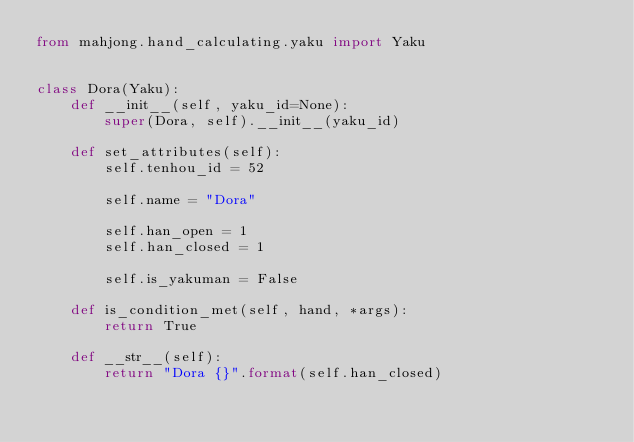<code> <loc_0><loc_0><loc_500><loc_500><_Python_>from mahjong.hand_calculating.yaku import Yaku


class Dora(Yaku):
    def __init__(self, yaku_id=None):
        super(Dora, self).__init__(yaku_id)

    def set_attributes(self):
        self.tenhou_id = 52

        self.name = "Dora"

        self.han_open = 1
        self.han_closed = 1

        self.is_yakuman = False

    def is_condition_met(self, hand, *args):
        return True

    def __str__(self):
        return "Dora {}".format(self.han_closed)
</code> 